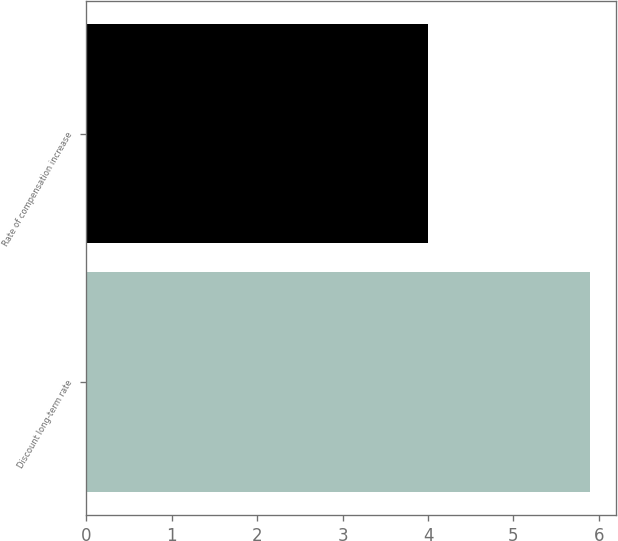Convert chart. <chart><loc_0><loc_0><loc_500><loc_500><bar_chart><fcel>Discount long-term rate<fcel>Rate of compensation increase<nl><fcel>5.9<fcel>4<nl></chart> 